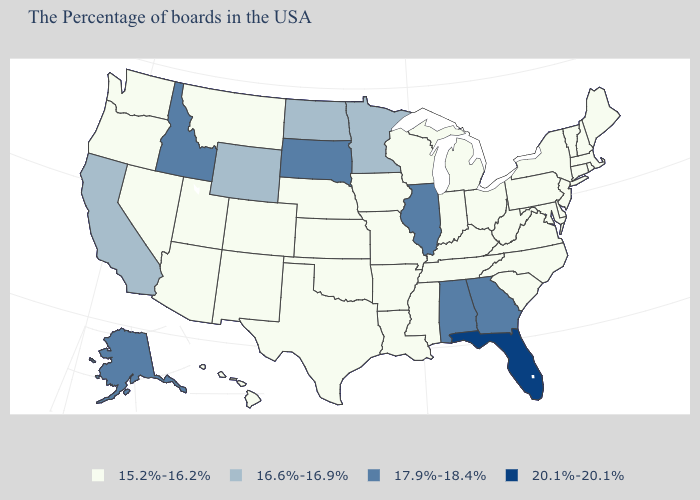Does New Hampshire have the same value as South Dakota?
Write a very short answer. No. What is the lowest value in states that border Delaware?
Keep it brief. 15.2%-16.2%. What is the value of Missouri?
Write a very short answer. 15.2%-16.2%. What is the value of Oregon?
Give a very brief answer. 15.2%-16.2%. Name the states that have a value in the range 17.9%-18.4%?
Concise answer only. Georgia, Alabama, Illinois, South Dakota, Idaho, Alaska. Name the states that have a value in the range 17.9%-18.4%?
Answer briefly. Georgia, Alabama, Illinois, South Dakota, Idaho, Alaska. Among the states that border Wyoming , which have the highest value?
Quick response, please. South Dakota, Idaho. Is the legend a continuous bar?
Short answer required. No. What is the value of Virginia?
Keep it brief. 15.2%-16.2%. Does the map have missing data?
Keep it brief. No. What is the lowest value in states that border New York?
Concise answer only. 15.2%-16.2%. What is the lowest value in the MidWest?
Short answer required. 15.2%-16.2%. Does Wisconsin have the highest value in the USA?
Short answer required. No. What is the lowest value in the South?
Answer briefly. 15.2%-16.2%. 